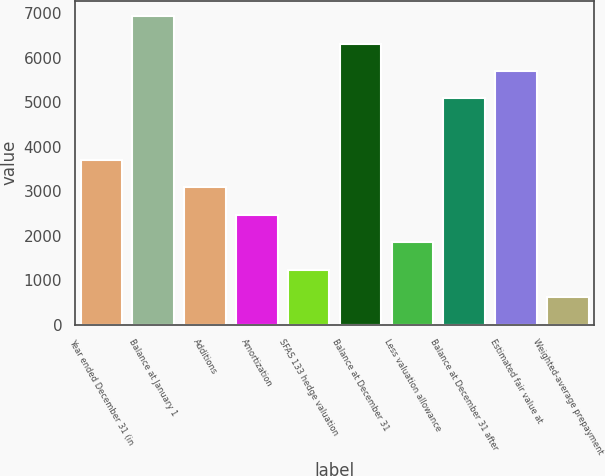Convert chart to OTSL. <chart><loc_0><loc_0><loc_500><loc_500><bar_chart><fcel>Year ended December 31 (in<fcel>Balance at January 1<fcel>Additions<fcel>Amortization<fcel>SFAS 133 hedge valuation<fcel>Balance at December 31<fcel>Less valuation allowance<fcel>Balance at December 31 after<fcel>Estimated fair value at<fcel>Weighted-average prepayment<nl><fcel>3698.59<fcel>6925.33<fcel>3083.48<fcel>2468.37<fcel>1238.15<fcel>6310.22<fcel>1853.26<fcel>5080<fcel>5695.11<fcel>623.04<nl></chart> 